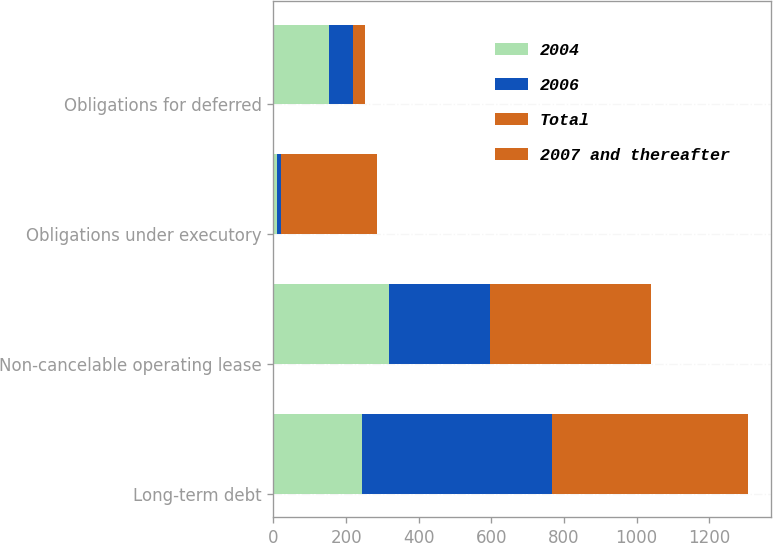Convert chart. <chart><loc_0><loc_0><loc_500><loc_500><stacked_bar_chart><ecel><fcel>Long-term debt<fcel>Non-cancelable operating lease<fcel>Obligations under executory<fcel>Obligations for deferred<nl><fcel>2004<fcel>244.5<fcel>317<fcel>10<fcel>154.2<nl><fcel>2006<fcel>523.8<fcel>279.9<fcel>11.3<fcel>64<nl><fcel>Total<fcel>338.5<fcel>244.3<fcel>12.8<fcel>17.4<nl><fcel>2007 and thereafter<fcel>199.25<fcel>199.25<fcel>251.1<fcel>16.6<nl></chart> 